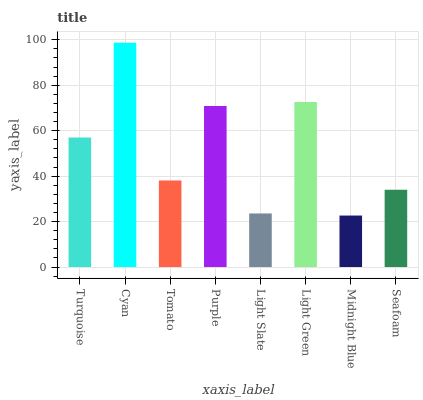Is Midnight Blue the minimum?
Answer yes or no. Yes. Is Cyan the maximum?
Answer yes or no. Yes. Is Tomato the minimum?
Answer yes or no. No. Is Tomato the maximum?
Answer yes or no. No. Is Cyan greater than Tomato?
Answer yes or no. Yes. Is Tomato less than Cyan?
Answer yes or no. Yes. Is Tomato greater than Cyan?
Answer yes or no. No. Is Cyan less than Tomato?
Answer yes or no. No. Is Turquoise the high median?
Answer yes or no. Yes. Is Tomato the low median?
Answer yes or no. Yes. Is Light Slate the high median?
Answer yes or no. No. Is Light Green the low median?
Answer yes or no. No. 